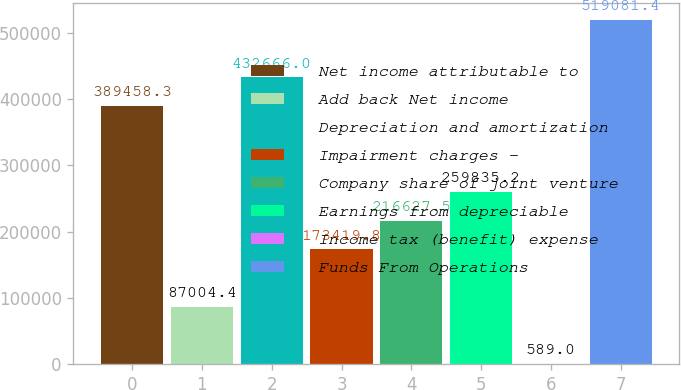Convert chart. <chart><loc_0><loc_0><loc_500><loc_500><bar_chart><fcel>Net income attributable to<fcel>Add back Net income<fcel>Depreciation and amortization<fcel>Impairment charges -<fcel>Company share of joint venture<fcel>Earnings from depreciable<fcel>Income tax (benefit) expense<fcel>Funds From Operations<nl><fcel>389458<fcel>87004.4<fcel>432666<fcel>173420<fcel>216628<fcel>259835<fcel>589<fcel>519081<nl></chart> 